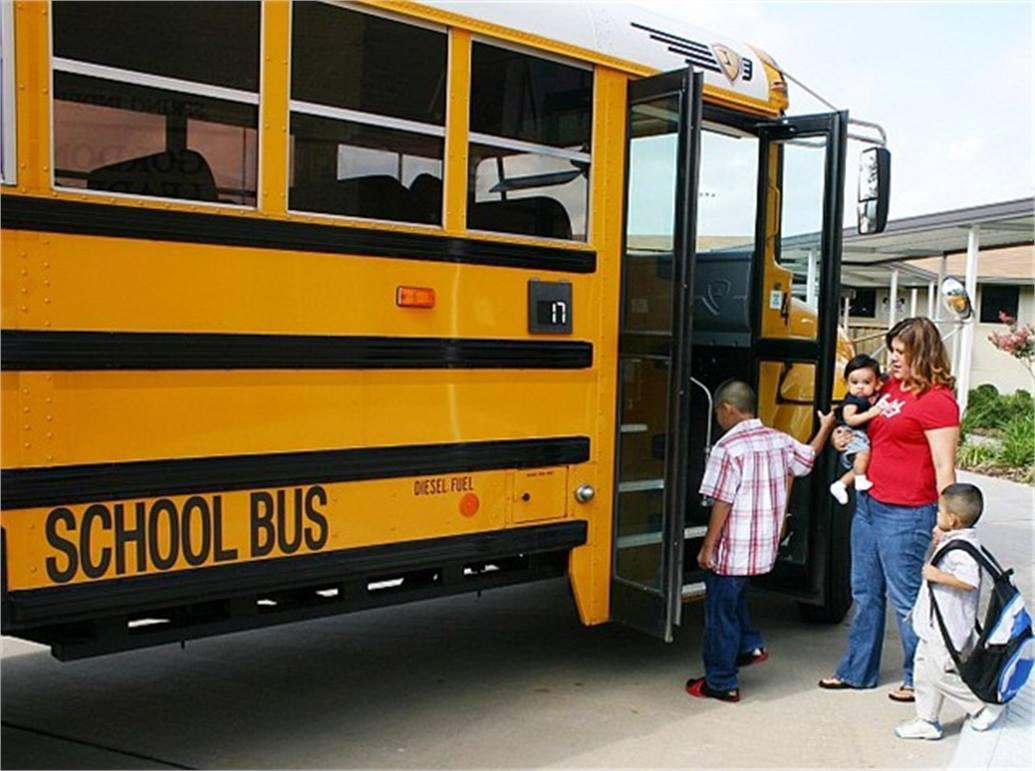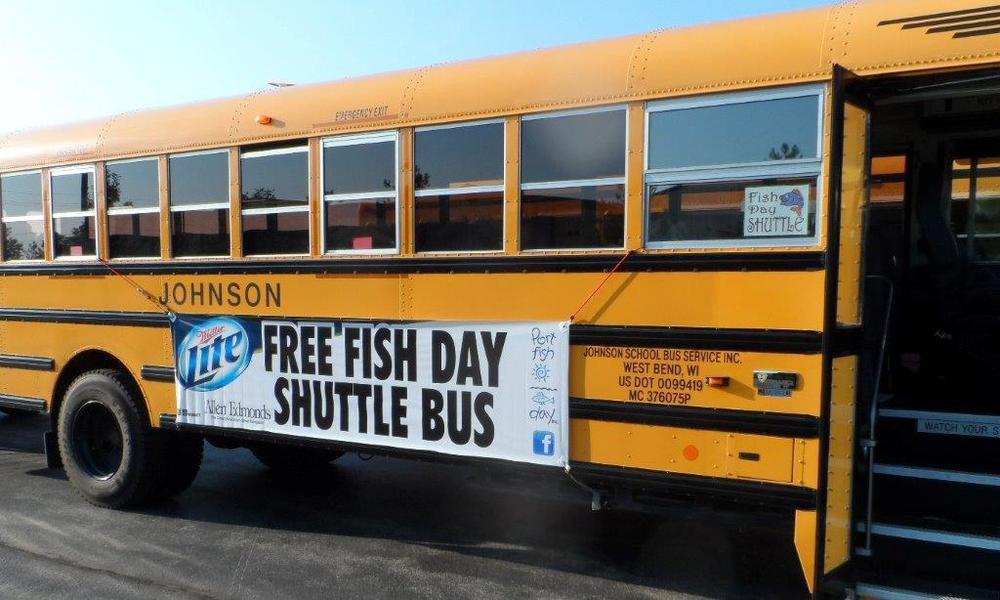The first image is the image on the left, the second image is the image on the right. For the images displayed, is the sentence "An image shows one horizontal bus with closed passenger doors at the right." factually correct? Answer yes or no. No. The first image is the image on the left, the second image is the image on the right. For the images displayed, is the sentence "There are more buses in the right image than in the left image." factually correct? Answer yes or no. No. 